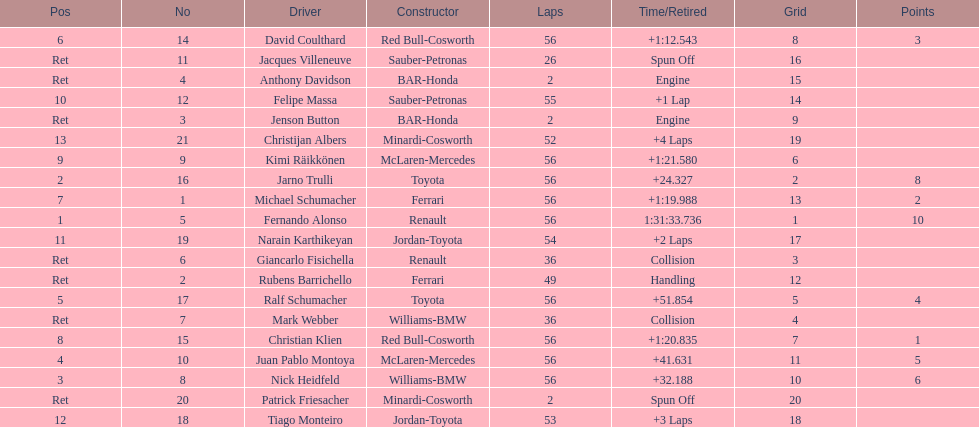Jarno trulli was not french but what nationality? Italian. 